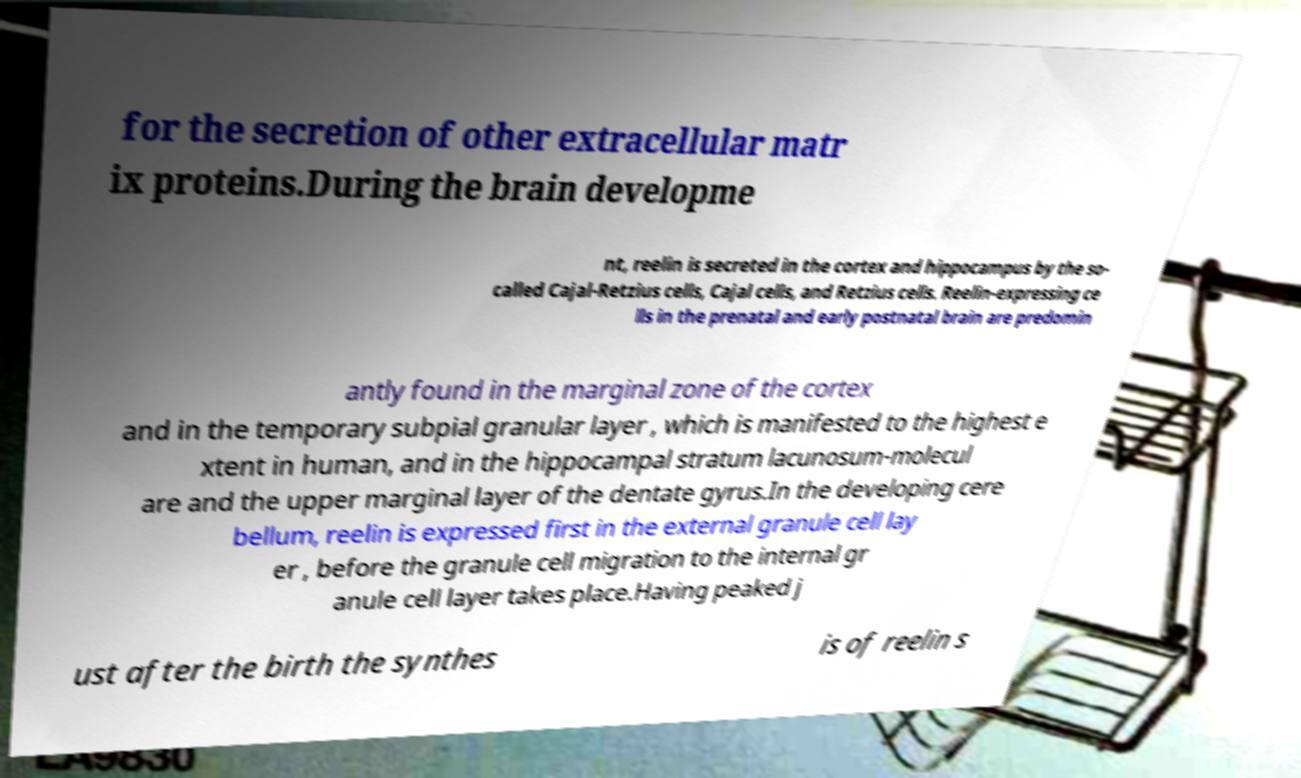Could you assist in decoding the text presented in this image and type it out clearly? for the secretion of other extracellular matr ix proteins.During the brain developme nt, reelin is secreted in the cortex and hippocampus by the so- called Cajal-Retzius cells, Cajal cells, and Retzius cells. Reelin-expressing ce lls in the prenatal and early postnatal brain are predomin antly found in the marginal zone of the cortex and in the temporary subpial granular layer , which is manifested to the highest e xtent in human, and in the hippocampal stratum lacunosum-molecul are and the upper marginal layer of the dentate gyrus.In the developing cere bellum, reelin is expressed first in the external granule cell lay er , before the granule cell migration to the internal gr anule cell layer takes place.Having peaked j ust after the birth the synthes is of reelin s 